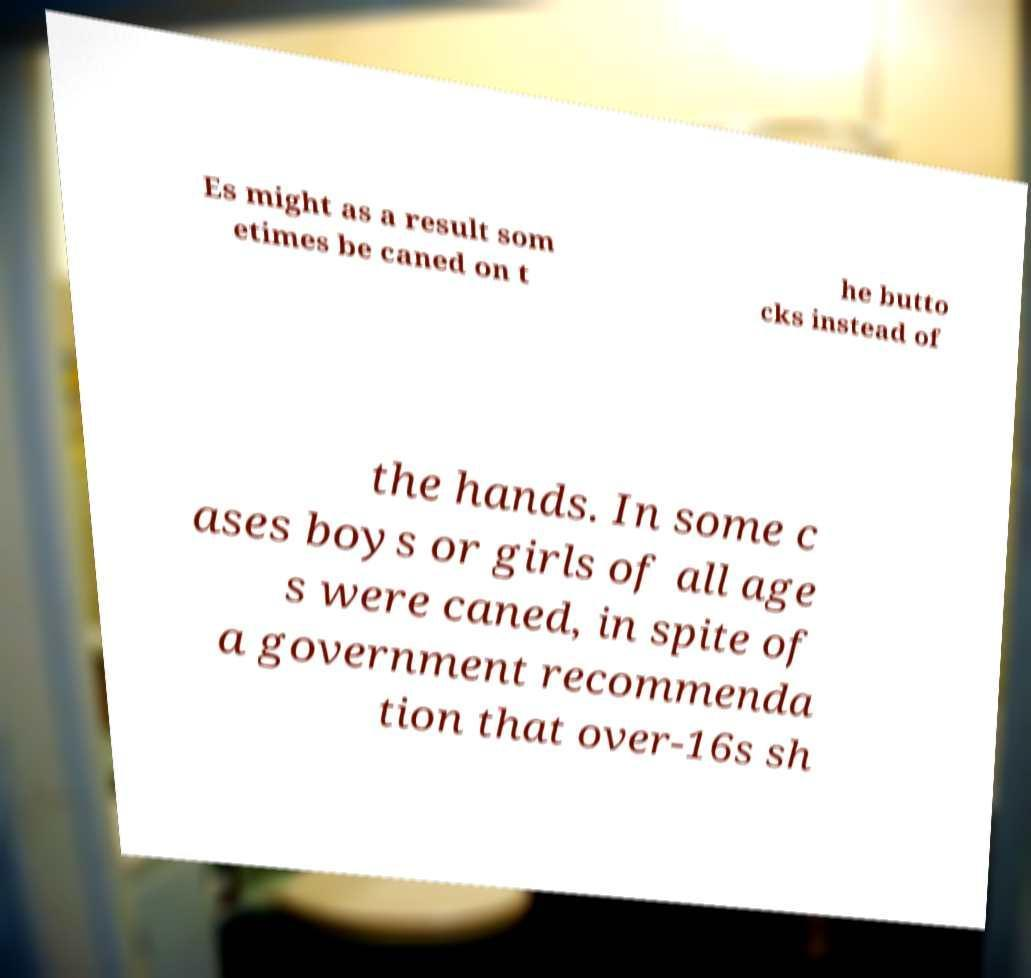For documentation purposes, I need the text within this image transcribed. Could you provide that? Es might as a result som etimes be caned on t he butto cks instead of the hands. In some c ases boys or girls of all age s were caned, in spite of a government recommenda tion that over-16s sh 